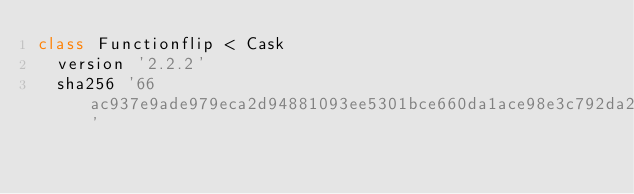Convert code to text. <code><loc_0><loc_0><loc_500><loc_500><_Ruby_>class Functionflip < Cask
  version '2.2.2'
  sha256 '66ac937e9ade979eca2d94881093ee5301bce660da1ace98e3c792da29b33c72'
</code> 